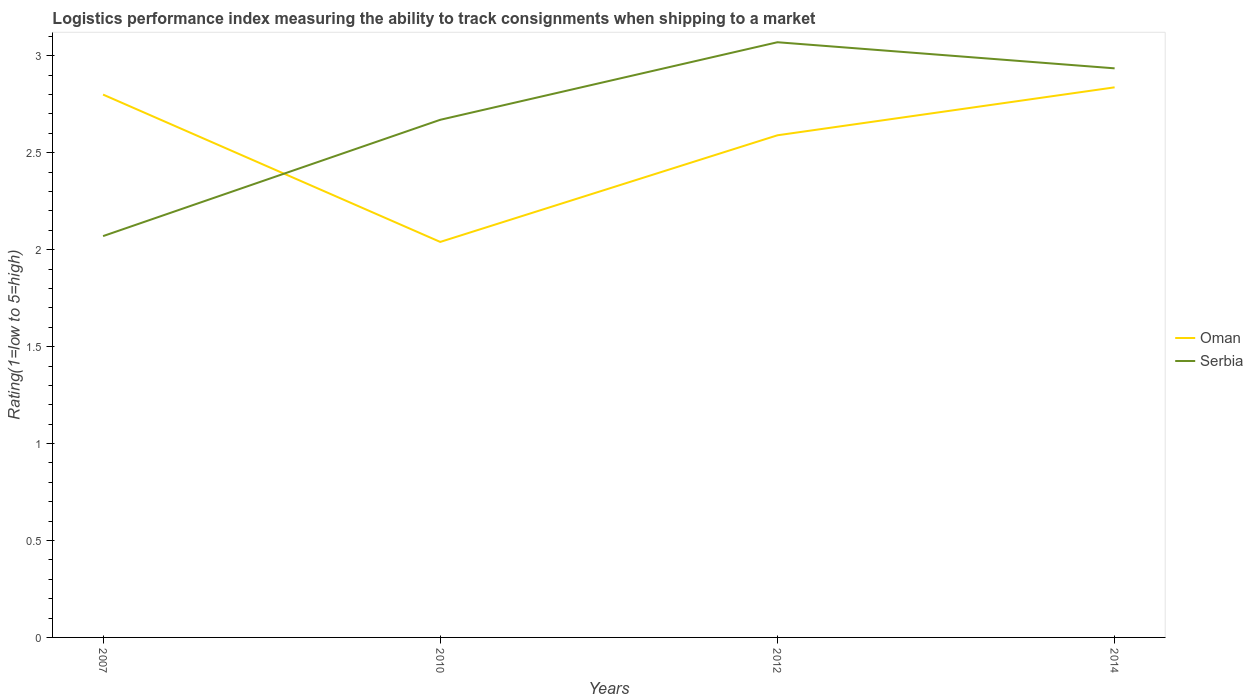How many different coloured lines are there?
Make the answer very short. 2. Is the number of lines equal to the number of legend labels?
Your answer should be very brief. Yes. Across all years, what is the maximum Logistic performance index in Oman?
Your answer should be very brief. 2.04. What is the total Logistic performance index in Serbia in the graph?
Offer a very short reply. -0.4. What is the difference between the highest and the second highest Logistic performance index in Oman?
Offer a very short reply. 0.8. Is the Logistic performance index in Serbia strictly greater than the Logistic performance index in Oman over the years?
Provide a short and direct response. No. How many years are there in the graph?
Give a very brief answer. 4. Are the values on the major ticks of Y-axis written in scientific E-notation?
Ensure brevity in your answer.  No. Does the graph contain grids?
Offer a very short reply. No. Where does the legend appear in the graph?
Ensure brevity in your answer.  Center right. How are the legend labels stacked?
Your response must be concise. Vertical. What is the title of the graph?
Give a very brief answer. Logistics performance index measuring the ability to track consignments when shipping to a market. Does "American Samoa" appear as one of the legend labels in the graph?
Ensure brevity in your answer.  No. What is the label or title of the X-axis?
Make the answer very short. Years. What is the label or title of the Y-axis?
Offer a very short reply. Rating(1=low to 5=high). What is the Rating(1=low to 5=high) of Serbia in 2007?
Your response must be concise. 2.07. What is the Rating(1=low to 5=high) in Oman in 2010?
Provide a succinct answer. 2.04. What is the Rating(1=low to 5=high) in Serbia in 2010?
Give a very brief answer. 2.67. What is the Rating(1=low to 5=high) in Oman in 2012?
Give a very brief answer. 2.59. What is the Rating(1=low to 5=high) of Serbia in 2012?
Offer a terse response. 3.07. What is the Rating(1=low to 5=high) of Oman in 2014?
Your answer should be compact. 2.84. What is the Rating(1=low to 5=high) of Serbia in 2014?
Your answer should be compact. 2.94. Across all years, what is the maximum Rating(1=low to 5=high) in Oman?
Keep it short and to the point. 2.84. Across all years, what is the maximum Rating(1=low to 5=high) of Serbia?
Ensure brevity in your answer.  3.07. Across all years, what is the minimum Rating(1=low to 5=high) in Oman?
Ensure brevity in your answer.  2.04. Across all years, what is the minimum Rating(1=low to 5=high) in Serbia?
Keep it short and to the point. 2.07. What is the total Rating(1=low to 5=high) of Oman in the graph?
Make the answer very short. 10.27. What is the total Rating(1=low to 5=high) in Serbia in the graph?
Make the answer very short. 10.75. What is the difference between the Rating(1=low to 5=high) in Oman in 2007 and that in 2010?
Offer a terse response. 0.76. What is the difference between the Rating(1=low to 5=high) of Oman in 2007 and that in 2012?
Your response must be concise. 0.21. What is the difference between the Rating(1=low to 5=high) of Oman in 2007 and that in 2014?
Your answer should be very brief. -0.04. What is the difference between the Rating(1=low to 5=high) in Serbia in 2007 and that in 2014?
Keep it short and to the point. -0.87. What is the difference between the Rating(1=low to 5=high) of Oman in 2010 and that in 2012?
Give a very brief answer. -0.55. What is the difference between the Rating(1=low to 5=high) of Oman in 2010 and that in 2014?
Your response must be concise. -0.8. What is the difference between the Rating(1=low to 5=high) in Serbia in 2010 and that in 2014?
Offer a terse response. -0.27. What is the difference between the Rating(1=low to 5=high) in Oman in 2012 and that in 2014?
Give a very brief answer. -0.25. What is the difference between the Rating(1=low to 5=high) of Serbia in 2012 and that in 2014?
Ensure brevity in your answer.  0.13. What is the difference between the Rating(1=low to 5=high) in Oman in 2007 and the Rating(1=low to 5=high) in Serbia in 2010?
Make the answer very short. 0.13. What is the difference between the Rating(1=low to 5=high) of Oman in 2007 and the Rating(1=low to 5=high) of Serbia in 2012?
Your answer should be compact. -0.27. What is the difference between the Rating(1=low to 5=high) of Oman in 2007 and the Rating(1=low to 5=high) of Serbia in 2014?
Offer a terse response. -0.14. What is the difference between the Rating(1=low to 5=high) in Oman in 2010 and the Rating(1=low to 5=high) in Serbia in 2012?
Keep it short and to the point. -1.03. What is the difference between the Rating(1=low to 5=high) of Oman in 2010 and the Rating(1=low to 5=high) of Serbia in 2014?
Offer a very short reply. -0.9. What is the difference between the Rating(1=low to 5=high) in Oman in 2012 and the Rating(1=low to 5=high) in Serbia in 2014?
Your answer should be compact. -0.35. What is the average Rating(1=low to 5=high) of Oman per year?
Your answer should be compact. 2.57. What is the average Rating(1=low to 5=high) of Serbia per year?
Offer a terse response. 2.69. In the year 2007, what is the difference between the Rating(1=low to 5=high) in Oman and Rating(1=low to 5=high) in Serbia?
Keep it short and to the point. 0.73. In the year 2010, what is the difference between the Rating(1=low to 5=high) in Oman and Rating(1=low to 5=high) in Serbia?
Provide a succinct answer. -0.63. In the year 2012, what is the difference between the Rating(1=low to 5=high) of Oman and Rating(1=low to 5=high) of Serbia?
Give a very brief answer. -0.48. In the year 2014, what is the difference between the Rating(1=low to 5=high) in Oman and Rating(1=low to 5=high) in Serbia?
Your answer should be very brief. -0.1. What is the ratio of the Rating(1=low to 5=high) of Oman in 2007 to that in 2010?
Provide a short and direct response. 1.37. What is the ratio of the Rating(1=low to 5=high) in Serbia in 2007 to that in 2010?
Your answer should be very brief. 0.78. What is the ratio of the Rating(1=low to 5=high) of Oman in 2007 to that in 2012?
Your answer should be very brief. 1.08. What is the ratio of the Rating(1=low to 5=high) of Serbia in 2007 to that in 2012?
Ensure brevity in your answer.  0.67. What is the ratio of the Rating(1=low to 5=high) of Oman in 2007 to that in 2014?
Ensure brevity in your answer.  0.99. What is the ratio of the Rating(1=low to 5=high) of Serbia in 2007 to that in 2014?
Offer a very short reply. 0.71. What is the ratio of the Rating(1=low to 5=high) of Oman in 2010 to that in 2012?
Your answer should be compact. 0.79. What is the ratio of the Rating(1=low to 5=high) in Serbia in 2010 to that in 2012?
Ensure brevity in your answer.  0.87. What is the ratio of the Rating(1=low to 5=high) of Oman in 2010 to that in 2014?
Provide a short and direct response. 0.72. What is the ratio of the Rating(1=low to 5=high) in Serbia in 2010 to that in 2014?
Make the answer very short. 0.91. What is the ratio of the Rating(1=low to 5=high) of Oman in 2012 to that in 2014?
Offer a very short reply. 0.91. What is the ratio of the Rating(1=low to 5=high) of Serbia in 2012 to that in 2014?
Your response must be concise. 1.05. What is the difference between the highest and the second highest Rating(1=low to 5=high) of Oman?
Provide a short and direct response. 0.04. What is the difference between the highest and the second highest Rating(1=low to 5=high) of Serbia?
Your answer should be very brief. 0.13. What is the difference between the highest and the lowest Rating(1=low to 5=high) in Oman?
Your answer should be compact. 0.8. 